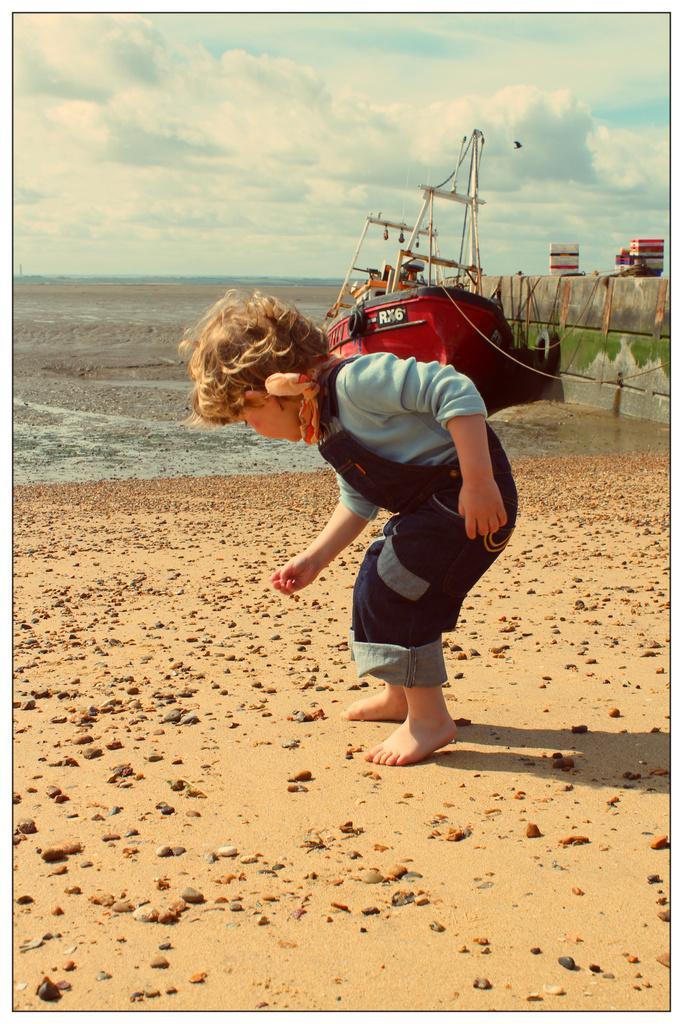Describe this image in one or two sentences. In this image there is a kid standing on the ground. On the ground there are so many stones. In the background there is a ship in the water. At the top there is the sky. On the right side there is a wall. 